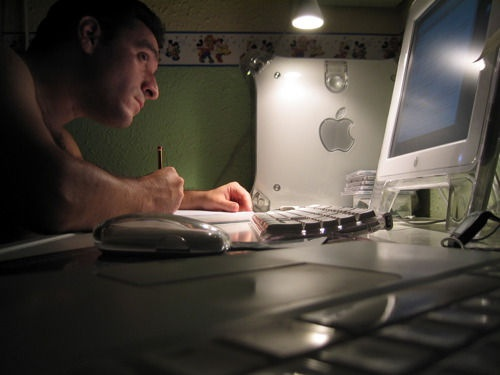Describe the objects in this image and their specific colors. I can see people in black, maroon, and brown tones, keyboard in black and gray tones, tv in black, gray, darkgray, and lightgray tones, mouse in black and gray tones, and keyboard in black, darkgray, gray, and lightgray tones in this image. 